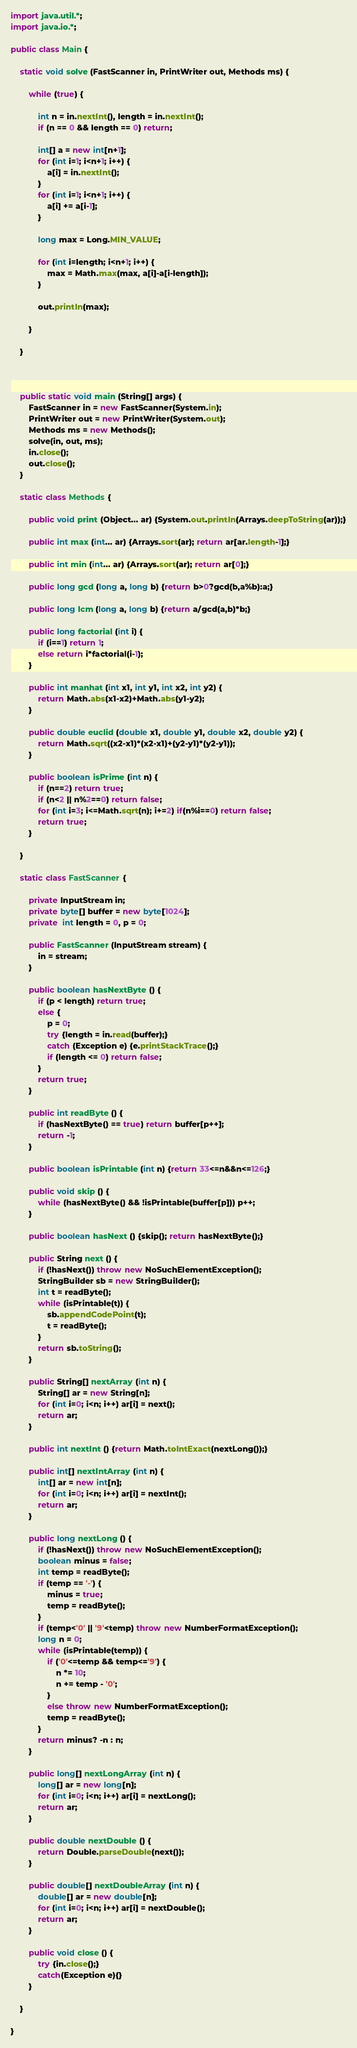<code> <loc_0><loc_0><loc_500><loc_500><_Java_>import java.util.*;
import java.io.*;

public class Main {

	static void solve (FastScanner in, PrintWriter out, Methods ms) {

		while (true) {
			
			int n = in.nextInt(), length = in.nextInt();
			if (n == 0 && length == 0) return;
			
			int[] a = new int[n+1];
			for (int i=1; i<n+1; i++) {
				a[i] = in.nextInt();
			}
			for (int i=1; i<n+1; i++) {
				a[i] += a[i-1];
			}
			
			long max = Long.MIN_VALUE;
			
			for (int i=length; i<n+1; i++) {
				max = Math.max(max, a[i]-a[i-length]);
			}
			
			out.println(max);
			
		}

	}



	public static void main (String[] args) {
		FastScanner in = new FastScanner(System.in);
		PrintWriter out = new PrintWriter(System.out);
		Methods ms = new Methods();
		solve(in, out, ms);
		in.close();
		out.close();
	}

	static class Methods {

		public void print (Object... ar) {System.out.println(Arrays.deepToString(ar));}

		public int max (int... ar) {Arrays.sort(ar); return ar[ar.length-1];}

		public int min (int... ar) {Arrays.sort(ar); return ar[0];}

		public long gcd (long a, long b) {return b>0?gcd(b,a%b):a;}

		public long lcm (long a, long b) {return a/gcd(a,b)*b;}

		public long factorial (int i) {
			if (i==1) return 1;
			else return i*factorial(i-1);
		}

		public int manhat (int x1, int y1, int x2, int y2) {
			return Math.abs(x1-x2)+Math.abs(y1-y2);
		}

		public double euclid (double x1, double y1, double x2, double y2) {
			return Math.sqrt((x2-x1)*(x2-x1)+(y2-y1)*(y2-y1));
		}

		public boolean isPrime (int n) {
			if (n==2) return true;
			if (n<2 || n%2==0) return false;
			for (int i=3; i<=Math.sqrt(n); i+=2) if(n%i==0) return false;
			return true;
		}

	}

	static class FastScanner {

		private InputStream in;
		private byte[] buffer = new byte[1024];
		private  int length = 0, p = 0;

		public FastScanner (InputStream stream) {
			in = stream;
		}

		public boolean hasNextByte () {
			if (p < length) return true;
			else {
				p = 0;
				try {length = in.read(buffer);}
				catch (Exception e) {e.printStackTrace();}
				if (length <= 0) return false;
			}
			return true;
		}

		public int readByte () {
			if (hasNextByte() == true) return buffer[p++];
			return -1;
		}

		public boolean isPrintable (int n) {return 33<=n&&n<=126;}

		public void skip () {
			while (hasNextByte() && !isPrintable(buffer[p])) p++;
		}

		public boolean hasNext () {skip(); return hasNextByte();}

		public String next () {
			if (!hasNext()) throw new NoSuchElementException();
			StringBuilder sb = new StringBuilder();
			int t = readByte();
			while (isPrintable(t)) {
				sb.appendCodePoint(t);
				t = readByte();
			}
			return sb.toString();
		}

		public String[] nextArray (int n) {
			String[] ar = new String[n];
			for (int i=0; i<n; i++) ar[i] = next();
			return ar;
		}

		public int nextInt () {return Math.toIntExact(nextLong());}

		public int[] nextIntArray (int n) {
			int[] ar = new int[n];
			for (int i=0; i<n; i++) ar[i] = nextInt();
			return ar;
		}

		public long nextLong () {
			if (!hasNext()) throw new NoSuchElementException();
			boolean minus = false;
			int temp = readByte();
			if (temp == '-') {
				minus = true;
				temp = readByte();
			}
			if (temp<'0' || '9'<temp) throw new NumberFormatException();
			long n = 0;
			while (isPrintable(temp)) {
				if ('0'<=temp && temp<='9') {
					n *= 10;
					n += temp - '0';
				}
				else throw new NumberFormatException();
				temp = readByte();
			}
			return minus? -n : n;
		}

		public long[] nextLongArray (int n) {
			long[] ar = new long[n];
			for (int i=0; i<n; i++) ar[i] = nextLong();
			return ar;
		}

		public double nextDouble () {
			return Double.parseDouble(next());
		}

		public double[] nextDoubleArray (int n) {
			double[] ar = new double[n];
			for (int i=0; i<n; i++) ar[i] = nextDouble();
			return ar;
		}

		public void close () {
			try {in.close();}
			catch(Exception e){}
		}

	}

}
</code> 